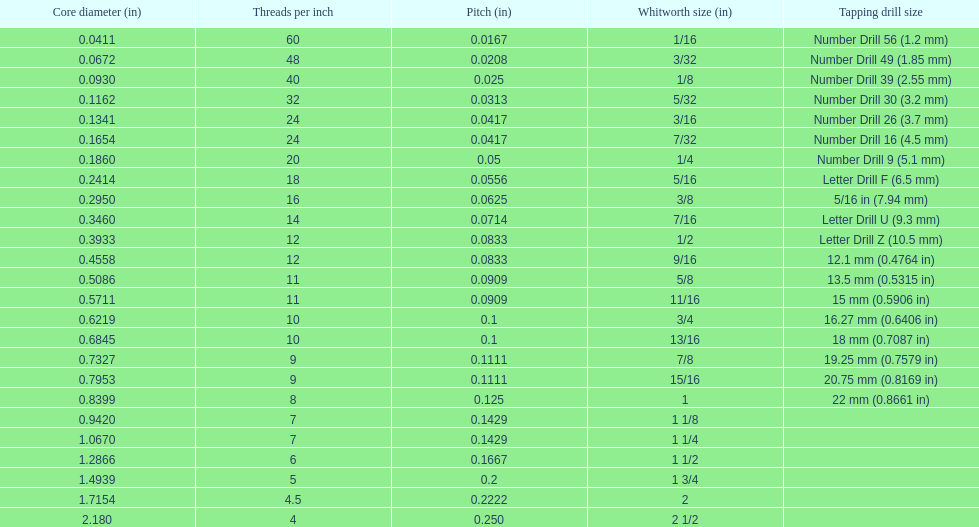Which whitworth size has the same number of threads per inch as 3/16? 7/32. 